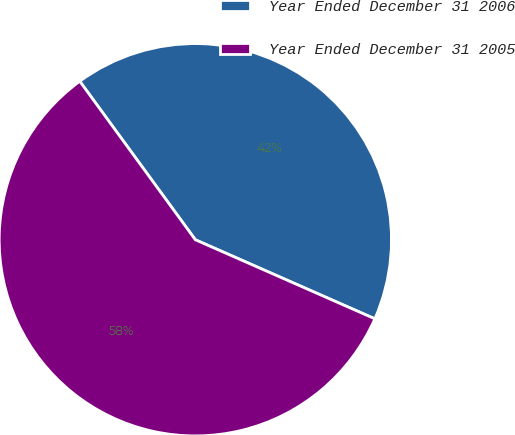Convert chart. <chart><loc_0><loc_0><loc_500><loc_500><pie_chart><fcel>Year Ended December 31 2006<fcel>Year Ended December 31 2005<nl><fcel>41.63%<fcel>58.37%<nl></chart> 